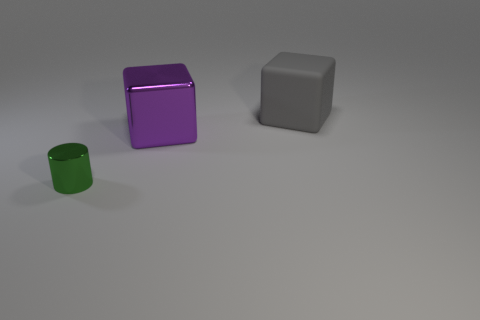There is a gray object; how many large things are in front of it?
Offer a very short reply. 1. Do the block on the left side of the large gray thing and the tiny metallic cylinder have the same color?
Your response must be concise. No. What number of purple things are blocks or small objects?
Provide a succinct answer. 1. There is a metal thing that is to the left of the big object on the left side of the big gray rubber cube; what color is it?
Keep it short and to the point. Green. There is a metallic thing that is behind the metal cylinder; what is its color?
Offer a terse response. Purple. There is a metal object that is on the right side of the cylinder; is its size the same as the tiny metal cylinder?
Offer a very short reply. No. Are there any other matte objects that have the same size as the purple thing?
Provide a succinct answer. Yes. Do the large thing in front of the large gray block and the big thing to the right of the big purple object have the same color?
Offer a terse response. No. Is there a big rubber cube that has the same color as the tiny metallic cylinder?
Make the answer very short. No. How many other objects are there of the same shape as the green shiny thing?
Ensure brevity in your answer.  0. 